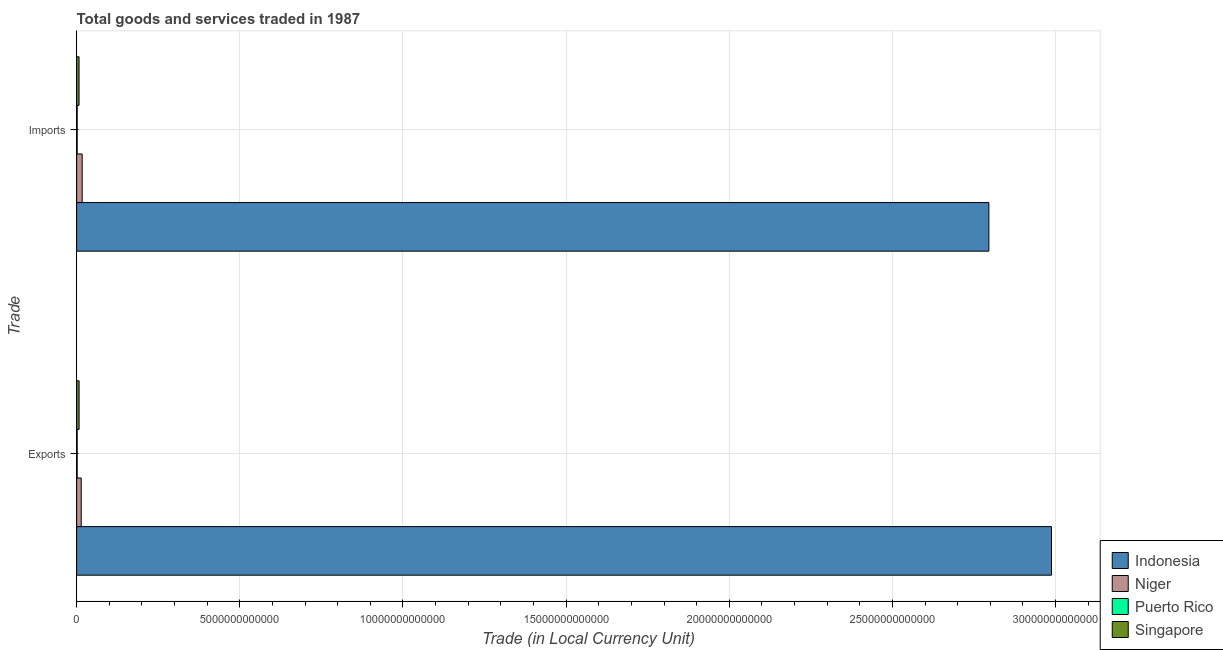How many different coloured bars are there?
Offer a terse response. 4. How many groups of bars are there?
Give a very brief answer. 2. Are the number of bars per tick equal to the number of legend labels?
Provide a short and direct response. Yes. How many bars are there on the 2nd tick from the top?
Give a very brief answer. 4. How many bars are there on the 1st tick from the bottom?
Provide a succinct answer. 4. What is the label of the 1st group of bars from the top?
Keep it short and to the point. Imports. What is the export of goods and services in Niger?
Ensure brevity in your answer.  1.40e+11. Across all countries, what is the maximum export of goods and services?
Give a very brief answer. 2.99e+13. Across all countries, what is the minimum imports of goods and services?
Make the answer very short. 1.55e+1. In which country was the export of goods and services minimum?
Your answer should be compact. Puerto Rico. What is the total export of goods and services in the graph?
Offer a terse response. 3.01e+13. What is the difference between the imports of goods and services in Niger and that in Puerto Rico?
Ensure brevity in your answer.  1.54e+11. What is the difference between the export of goods and services in Puerto Rico and the imports of goods and services in Niger?
Your answer should be very brief. -1.53e+11. What is the average imports of goods and services per country?
Offer a terse response. 7.05e+12. What is the difference between the export of goods and services and imports of goods and services in Puerto Rico?
Keep it short and to the point. 3.70e+08. What is the ratio of the imports of goods and services in Singapore to that in Indonesia?
Offer a very short reply. 0. Is the export of goods and services in Niger less than that in Singapore?
Provide a short and direct response. No. What does the 2nd bar from the top in Imports represents?
Ensure brevity in your answer.  Puerto Rico. What does the 3rd bar from the bottom in Exports represents?
Make the answer very short. Puerto Rico. How many bars are there?
Provide a short and direct response. 8. Are all the bars in the graph horizontal?
Your answer should be compact. Yes. What is the difference between two consecutive major ticks on the X-axis?
Give a very brief answer. 5.00e+12. Are the values on the major ticks of X-axis written in scientific E-notation?
Offer a terse response. No. Where does the legend appear in the graph?
Your answer should be compact. Bottom right. How are the legend labels stacked?
Provide a short and direct response. Vertical. What is the title of the graph?
Ensure brevity in your answer.  Total goods and services traded in 1987. What is the label or title of the X-axis?
Offer a terse response. Trade (in Local Currency Unit). What is the label or title of the Y-axis?
Offer a terse response. Trade. What is the Trade (in Local Currency Unit) of Indonesia in Exports?
Make the answer very short. 2.99e+13. What is the Trade (in Local Currency Unit) in Niger in Exports?
Offer a very short reply. 1.40e+11. What is the Trade (in Local Currency Unit) of Puerto Rico in Exports?
Your response must be concise. 1.58e+1. What is the Trade (in Local Currency Unit) of Singapore in Exports?
Provide a short and direct response. 7.47e+1. What is the Trade (in Local Currency Unit) in Indonesia in Imports?
Offer a very short reply. 2.80e+13. What is the Trade (in Local Currency Unit) in Niger in Imports?
Your answer should be compact. 1.69e+11. What is the Trade (in Local Currency Unit) of Puerto Rico in Imports?
Provide a short and direct response. 1.55e+1. What is the Trade (in Local Currency Unit) in Singapore in Imports?
Your answer should be compact. 7.34e+1. Across all Trade, what is the maximum Trade (in Local Currency Unit) of Indonesia?
Your answer should be compact. 2.99e+13. Across all Trade, what is the maximum Trade (in Local Currency Unit) in Niger?
Make the answer very short. 1.69e+11. Across all Trade, what is the maximum Trade (in Local Currency Unit) of Puerto Rico?
Ensure brevity in your answer.  1.58e+1. Across all Trade, what is the maximum Trade (in Local Currency Unit) in Singapore?
Provide a succinct answer. 7.47e+1. Across all Trade, what is the minimum Trade (in Local Currency Unit) in Indonesia?
Make the answer very short. 2.80e+13. Across all Trade, what is the minimum Trade (in Local Currency Unit) in Niger?
Your answer should be compact. 1.40e+11. Across all Trade, what is the minimum Trade (in Local Currency Unit) in Puerto Rico?
Keep it short and to the point. 1.55e+1. Across all Trade, what is the minimum Trade (in Local Currency Unit) in Singapore?
Ensure brevity in your answer.  7.34e+1. What is the total Trade (in Local Currency Unit) of Indonesia in the graph?
Provide a succinct answer. 5.78e+13. What is the total Trade (in Local Currency Unit) in Niger in the graph?
Provide a succinct answer. 3.09e+11. What is the total Trade (in Local Currency Unit) in Puerto Rico in the graph?
Your answer should be compact. 3.13e+1. What is the total Trade (in Local Currency Unit) in Singapore in the graph?
Offer a terse response. 1.48e+11. What is the difference between the Trade (in Local Currency Unit) of Indonesia in Exports and that in Imports?
Give a very brief answer. 1.92e+12. What is the difference between the Trade (in Local Currency Unit) in Niger in Exports and that in Imports?
Give a very brief answer. -2.94e+1. What is the difference between the Trade (in Local Currency Unit) in Puerto Rico in Exports and that in Imports?
Give a very brief answer. 3.70e+08. What is the difference between the Trade (in Local Currency Unit) of Singapore in Exports and that in Imports?
Offer a very short reply. 1.35e+09. What is the difference between the Trade (in Local Currency Unit) in Indonesia in Exports and the Trade (in Local Currency Unit) in Niger in Imports?
Provide a succinct answer. 2.97e+13. What is the difference between the Trade (in Local Currency Unit) of Indonesia in Exports and the Trade (in Local Currency Unit) of Puerto Rico in Imports?
Your response must be concise. 2.99e+13. What is the difference between the Trade (in Local Currency Unit) in Indonesia in Exports and the Trade (in Local Currency Unit) in Singapore in Imports?
Give a very brief answer. 2.98e+13. What is the difference between the Trade (in Local Currency Unit) in Niger in Exports and the Trade (in Local Currency Unit) in Puerto Rico in Imports?
Your answer should be compact. 1.24e+11. What is the difference between the Trade (in Local Currency Unit) in Niger in Exports and the Trade (in Local Currency Unit) in Singapore in Imports?
Ensure brevity in your answer.  6.63e+1. What is the difference between the Trade (in Local Currency Unit) in Puerto Rico in Exports and the Trade (in Local Currency Unit) in Singapore in Imports?
Provide a short and direct response. -5.75e+1. What is the average Trade (in Local Currency Unit) in Indonesia per Trade?
Make the answer very short. 2.89e+13. What is the average Trade (in Local Currency Unit) of Niger per Trade?
Provide a short and direct response. 1.54e+11. What is the average Trade (in Local Currency Unit) of Puerto Rico per Trade?
Your answer should be compact. 1.57e+1. What is the average Trade (in Local Currency Unit) of Singapore per Trade?
Make the answer very short. 7.40e+1. What is the difference between the Trade (in Local Currency Unit) in Indonesia and Trade (in Local Currency Unit) in Niger in Exports?
Provide a succinct answer. 2.97e+13. What is the difference between the Trade (in Local Currency Unit) in Indonesia and Trade (in Local Currency Unit) in Puerto Rico in Exports?
Your answer should be very brief. 2.99e+13. What is the difference between the Trade (in Local Currency Unit) of Indonesia and Trade (in Local Currency Unit) of Singapore in Exports?
Keep it short and to the point. 2.98e+13. What is the difference between the Trade (in Local Currency Unit) in Niger and Trade (in Local Currency Unit) in Puerto Rico in Exports?
Your answer should be very brief. 1.24e+11. What is the difference between the Trade (in Local Currency Unit) of Niger and Trade (in Local Currency Unit) of Singapore in Exports?
Ensure brevity in your answer.  6.49e+1. What is the difference between the Trade (in Local Currency Unit) of Puerto Rico and Trade (in Local Currency Unit) of Singapore in Exports?
Give a very brief answer. -5.89e+1. What is the difference between the Trade (in Local Currency Unit) of Indonesia and Trade (in Local Currency Unit) of Niger in Imports?
Make the answer very short. 2.78e+13. What is the difference between the Trade (in Local Currency Unit) of Indonesia and Trade (in Local Currency Unit) of Puerto Rico in Imports?
Give a very brief answer. 2.79e+13. What is the difference between the Trade (in Local Currency Unit) in Indonesia and Trade (in Local Currency Unit) in Singapore in Imports?
Keep it short and to the point. 2.79e+13. What is the difference between the Trade (in Local Currency Unit) of Niger and Trade (in Local Currency Unit) of Puerto Rico in Imports?
Provide a succinct answer. 1.54e+11. What is the difference between the Trade (in Local Currency Unit) of Niger and Trade (in Local Currency Unit) of Singapore in Imports?
Ensure brevity in your answer.  9.56e+1. What is the difference between the Trade (in Local Currency Unit) of Puerto Rico and Trade (in Local Currency Unit) of Singapore in Imports?
Offer a very short reply. -5.79e+1. What is the ratio of the Trade (in Local Currency Unit) of Indonesia in Exports to that in Imports?
Keep it short and to the point. 1.07. What is the ratio of the Trade (in Local Currency Unit) in Niger in Exports to that in Imports?
Your answer should be very brief. 0.83. What is the ratio of the Trade (in Local Currency Unit) of Puerto Rico in Exports to that in Imports?
Provide a succinct answer. 1.02. What is the ratio of the Trade (in Local Currency Unit) in Singapore in Exports to that in Imports?
Offer a very short reply. 1.02. What is the difference between the highest and the second highest Trade (in Local Currency Unit) in Indonesia?
Your answer should be compact. 1.92e+12. What is the difference between the highest and the second highest Trade (in Local Currency Unit) in Niger?
Ensure brevity in your answer.  2.94e+1. What is the difference between the highest and the second highest Trade (in Local Currency Unit) in Puerto Rico?
Provide a short and direct response. 3.70e+08. What is the difference between the highest and the second highest Trade (in Local Currency Unit) of Singapore?
Make the answer very short. 1.35e+09. What is the difference between the highest and the lowest Trade (in Local Currency Unit) of Indonesia?
Your response must be concise. 1.92e+12. What is the difference between the highest and the lowest Trade (in Local Currency Unit) in Niger?
Provide a short and direct response. 2.94e+1. What is the difference between the highest and the lowest Trade (in Local Currency Unit) in Puerto Rico?
Provide a succinct answer. 3.70e+08. What is the difference between the highest and the lowest Trade (in Local Currency Unit) of Singapore?
Offer a terse response. 1.35e+09. 